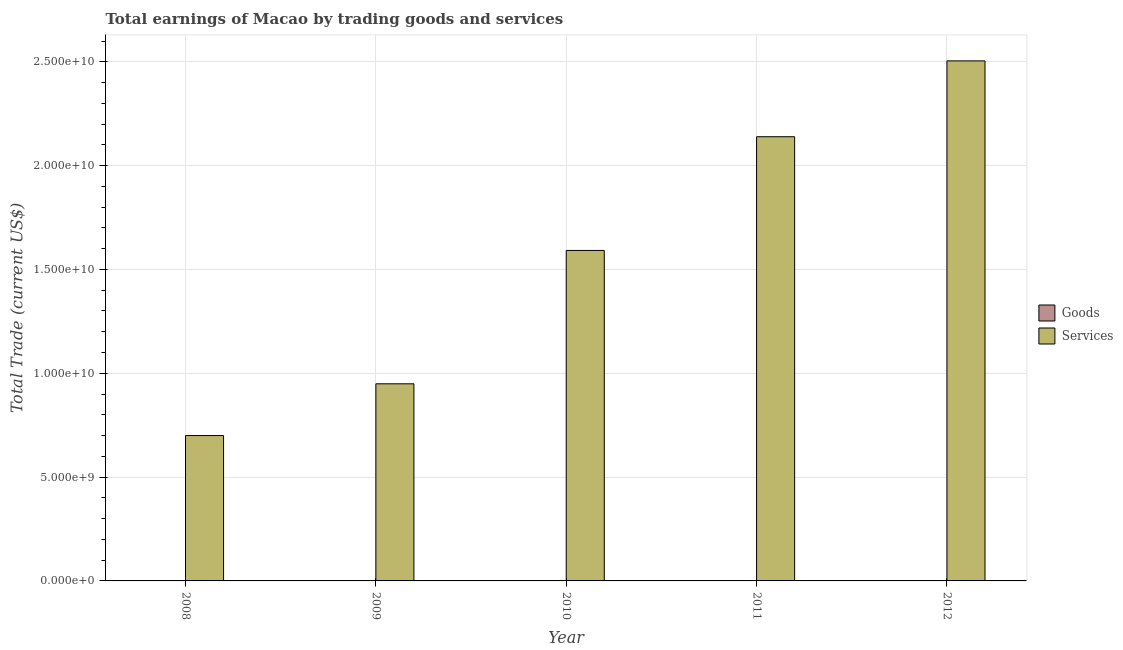Are the number of bars on each tick of the X-axis equal?
Your answer should be very brief. Yes. How many bars are there on the 3rd tick from the right?
Provide a succinct answer. 1. What is the label of the 2nd group of bars from the left?
Your response must be concise. 2009. In how many cases, is the number of bars for a given year not equal to the number of legend labels?
Keep it short and to the point. 5. Across all years, what is the maximum amount earned by trading services?
Make the answer very short. 2.50e+1. Across all years, what is the minimum amount earned by trading services?
Offer a very short reply. 7.00e+09. What is the total amount earned by trading services in the graph?
Provide a short and direct response. 7.88e+1. What is the difference between the amount earned by trading services in 2008 and that in 2009?
Ensure brevity in your answer.  -2.49e+09. What is the difference between the amount earned by trading goods in 2011 and the amount earned by trading services in 2009?
Make the answer very short. 0. In the year 2012, what is the difference between the amount earned by trading services and amount earned by trading goods?
Give a very brief answer. 0. In how many years, is the amount earned by trading services greater than 17000000000 US$?
Offer a very short reply. 2. What is the ratio of the amount earned by trading services in 2011 to that in 2012?
Provide a succinct answer. 0.85. Is the amount earned by trading services in 2009 less than that in 2011?
Offer a very short reply. Yes. What is the difference between the highest and the second highest amount earned by trading services?
Your answer should be very brief. 3.65e+09. What is the difference between the highest and the lowest amount earned by trading services?
Make the answer very short. 1.80e+1. In how many years, is the amount earned by trading goods greater than the average amount earned by trading goods taken over all years?
Make the answer very short. 0. How many bars are there?
Your answer should be very brief. 5. Are all the bars in the graph horizontal?
Provide a succinct answer. No. What is the difference between two consecutive major ticks on the Y-axis?
Offer a terse response. 5.00e+09. Does the graph contain any zero values?
Offer a terse response. Yes. Does the graph contain grids?
Provide a succinct answer. Yes. How many legend labels are there?
Give a very brief answer. 2. How are the legend labels stacked?
Offer a terse response. Vertical. What is the title of the graph?
Offer a very short reply. Total earnings of Macao by trading goods and services. Does "Quality of trade" appear as one of the legend labels in the graph?
Your answer should be very brief. No. What is the label or title of the Y-axis?
Your answer should be compact. Total Trade (current US$). What is the Total Trade (current US$) of Services in 2008?
Offer a terse response. 7.00e+09. What is the Total Trade (current US$) of Goods in 2009?
Provide a short and direct response. 0. What is the Total Trade (current US$) of Services in 2009?
Your response must be concise. 9.49e+09. What is the Total Trade (current US$) in Goods in 2010?
Provide a short and direct response. 0. What is the Total Trade (current US$) in Services in 2010?
Ensure brevity in your answer.  1.59e+1. What is the Total Trade (current US$) in Services in 2011?
Offer a terse response. 2.14e+1. What is the Total Trade (current US$) of Goods in 2012?
Your answer should be very brief. 0. What is the Total Trade (current US$) of Services in 2012?
Offer a terse response. 2.50e+1. Across all years, what is the maximum Total Trade (current US$) of Services?
Provide a short and direct response. 2.50e+1. Across all years, what is the minimum Total Trade (current US$) of Services?
Provide a short and direct response. 7.00e+09. What is the total Total Trade (current US$) in Services in the graph?
Ensure brevity in your answer.  7.88e+1. What is the difference between the Total Trade (current US$) in Services in 2008 and that in 2009?
Ensure brevity in your answer.  -2.49e+09. What is the difference between the Total Trade (current US$) in Services in 2008 and that in 2010?
Ensure brevity in your answer.  -8.92e+09. What is the difference between the Total Trade (current US$) of Services in 2008 and that in 2011?
Keep it short and to the point. -1.44e+1. What is the difference between the Total Trade (current US$) in Services in 2008 and that in 2012?
Offer a very short reply. -1.80e+1. What is the difference between the Total Trade (current US$) in Services in 2009 and that in 2010?
Your answer should be compact. -6.42e+09. What is the difference between the Total Trade (current US$) in Services in 2009 and that in 2011?
Make the answer very short. -1.19e+1. What is the difference between the Total Trade (current US$) of Services in 2009 and that in 2012?
Provide a short and direct response. -1.56e+1. What is the difference between the Total Trade (current US$) of Services in 2010 and that in 2011?
Your response must be concise. -5.48e+09. What is the difference between the Total Trade (current US$) of Services in 2010 and that in 2012?
Your answer should be compact. -9.13e+09. What is the difference between the Total Trade (current US$) in Services in 2011 and that in 2012?
Offer a terse response. -3.65e+09. What is the average Total Trade (current US$) in Services per year?
Give a very brief answer. 1.58e+1. What is the ratio of the Total Trade (current US$) in Services in 2008 to that in 2009?
Your answer should be very brief. 0.74. What is the ratio of the Total Trade (current US$) in Services in 2008 to that in 2010?
Provide a short and direct response. 0.44. What is the ratio of the Total Trade (current US$) of Services in 2008 to that in 2011?
Give a very brief answer. 0.33. What is the ratio of the Total Trade (current US$) in Services in 2008 to that in 2012?
Give a very brief answer. 0.28. What is the ratio of the Total Trade (current US$) in Services in 2009 to that in 2010?
Your response must be concise. 0.6. What is the ratio of the Total Trade (current US$) in Services in 2009 to that in 2011?
Give a very brief answer. 0.44. What is the ratio of the Total Trade (current US$) in Services in 2009 to that in 2012?
Your answer should be compact. 0.38. What is the ratio of the Total Trade (current US$) in Services in 2010 to that in 2011?
Offer a very short reply. 0.74. What is the ratio of the Total Trade (current US$) of Services in 2010 to that in 2012?
Provide a succinct answer. 0.64. What is the ratio of the Total Trade (current US$) in Services in 2011 to that in 2012?
Your answer should be compact. 0.85. What is the difference between the highest and the second highest Total Trade (current US$) of Services?
Ensure brevity in your answer.  3.65e+09. What is the difference between the highest and the lowest Total Trade (current US$) in Services?
Keep it short and to the point. 1.80e+1. 